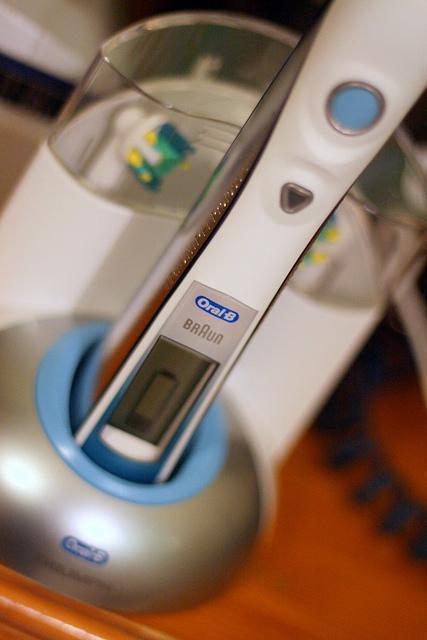How many toothbrushes are in the photo?
Give a very brief answer. 2. How many train tracks do you see?
Give a very brief answer. 0. 